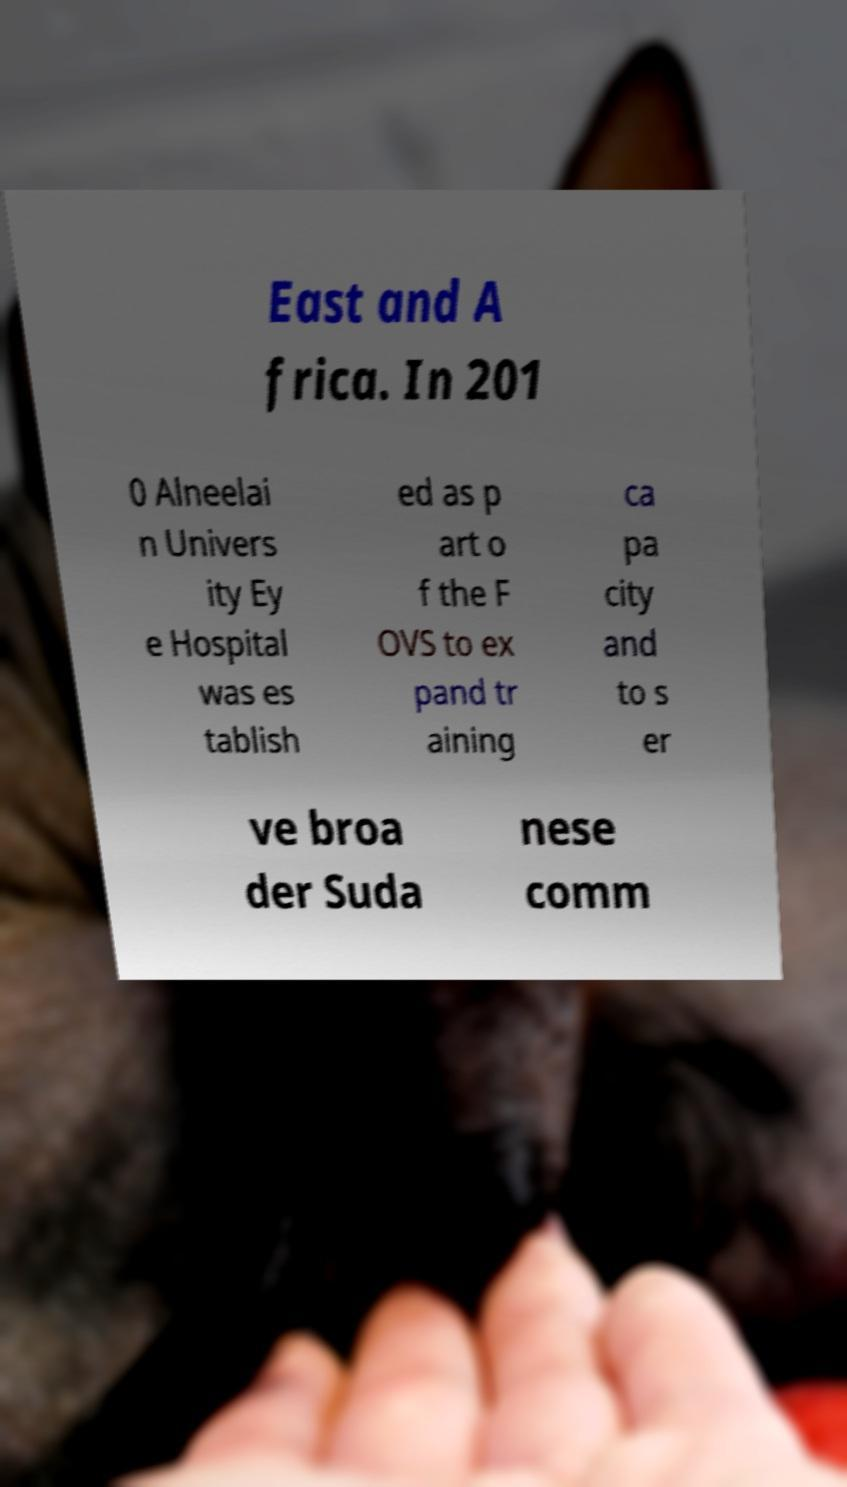Could you assist in decoding the text presented in this image and type it out clearly? East and A frica. In 201 0 Alneelai n Univers ity Ey e Hospital was es tablish ed as p art o f the F OVS to ex pand tr aining ca pa city and to s er ve broa der Suda nese comm 